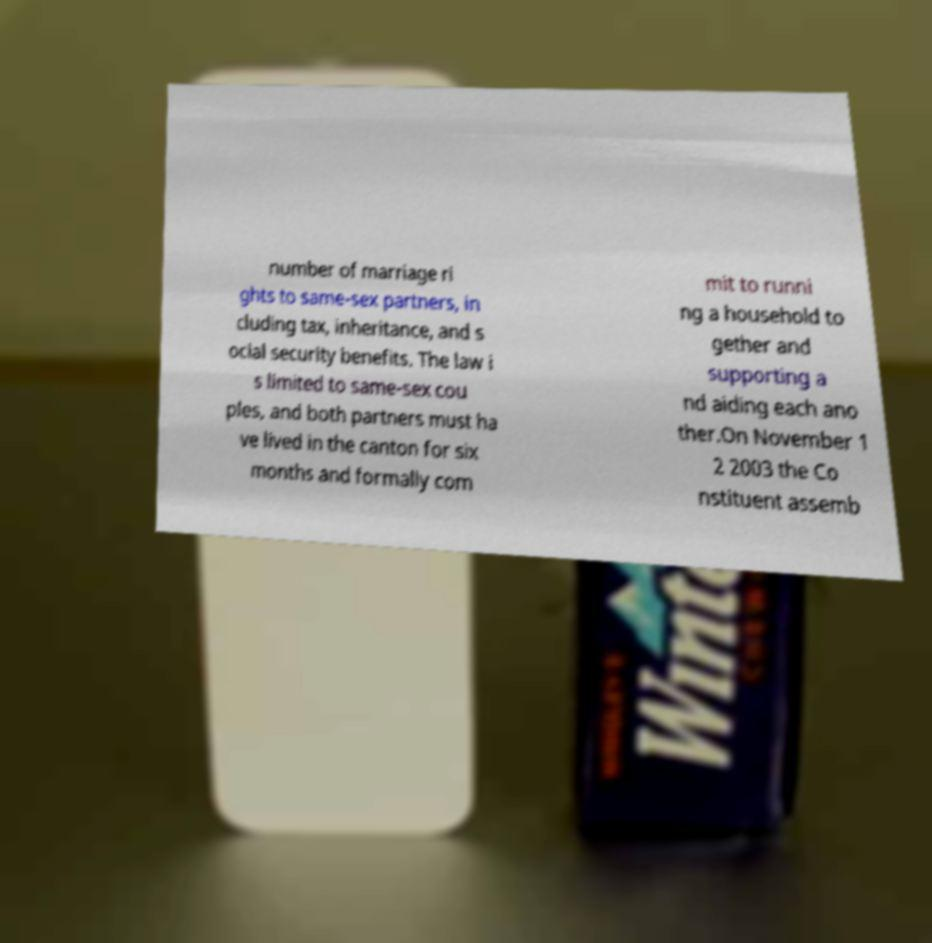Please read and relay the text visible in this image. What does it say? number of marriage ri ghts to same-sex partners, in cluding tax, inheritance, and s ocial security benefits. The law i s limited to same-sex cou ples, and both partners must ha ve lived in the canton for six months and formally com mit to runni ng a household to gether and supporting a nd aiding each ano ther.On November 1 2 2003 the Co nstituent assemb 